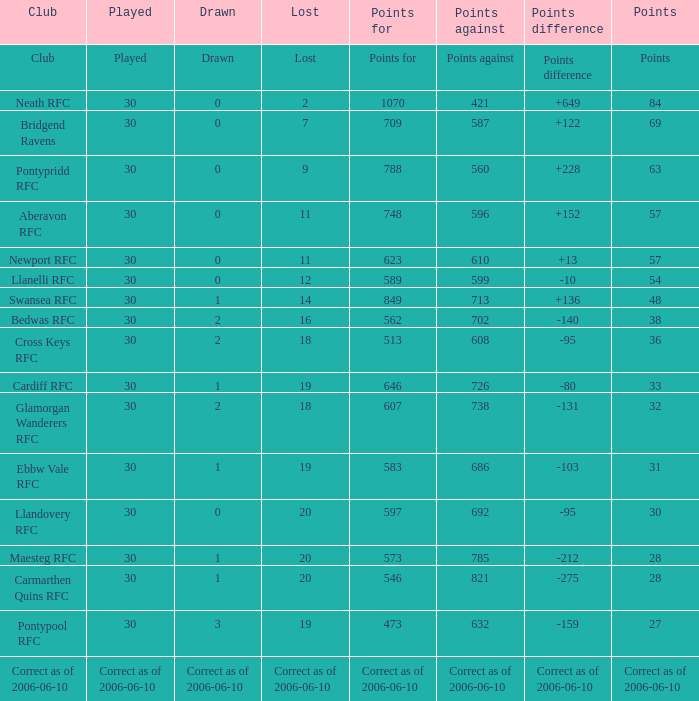What is Points For, when Points is "63"? 788.0. 